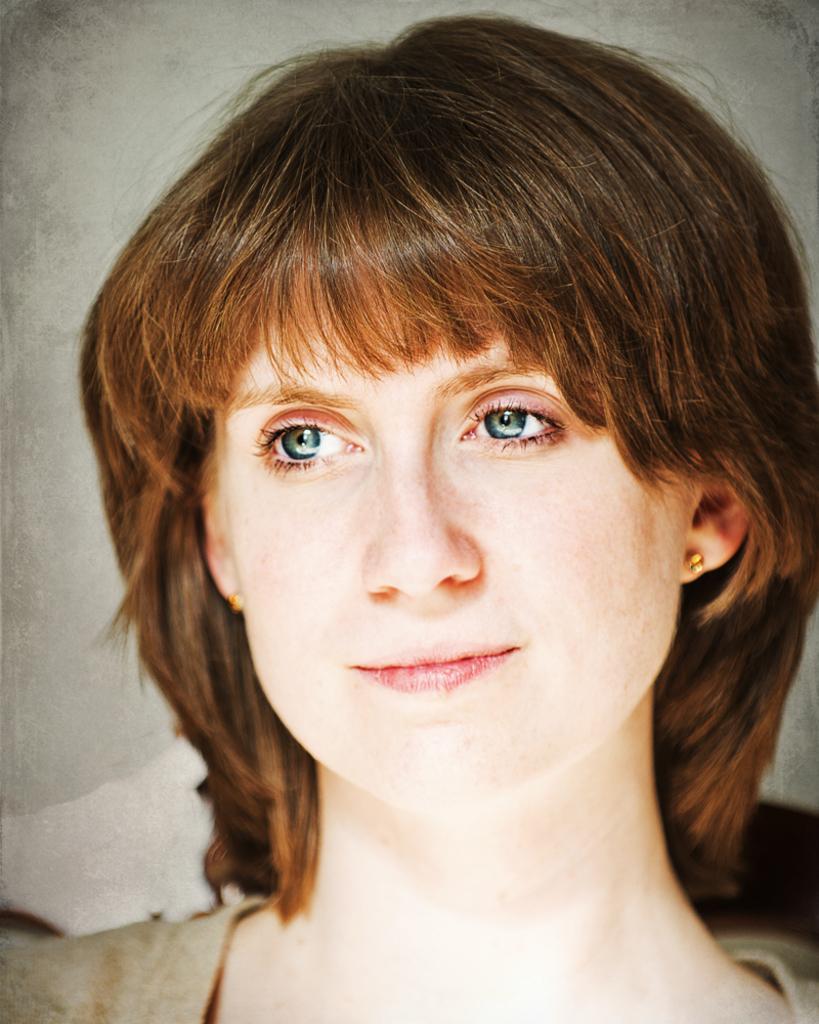In one or two sentences, can you explain what this image depicts? As we can see in the image there is a woman face. 